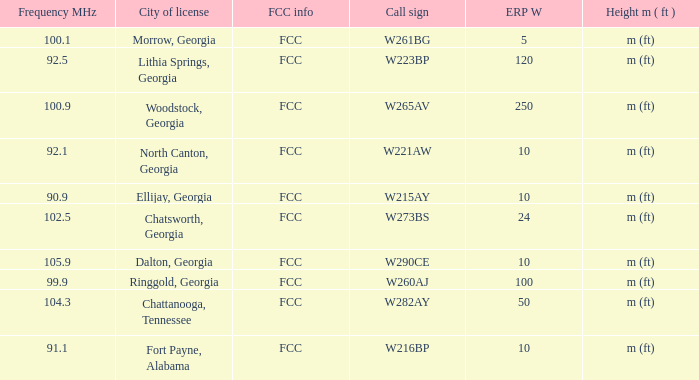How many ERP W is it that has a Call sign of w273bs? 24.0. 